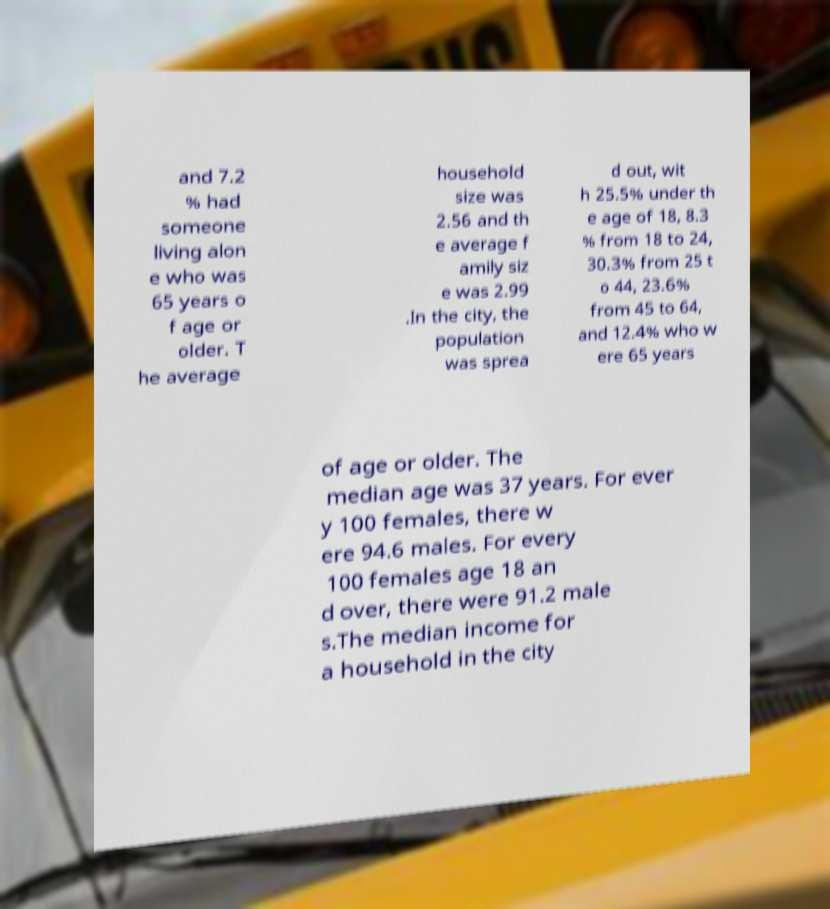What messages or text are displayed in this image? I need them in a readable, typed format. and 7.2 % had someone living alon e who was 65 years o f age or older. T he average household size was 2.56 and th e average f amily siz e was 2.99 .In the city, the population was sprea d out, wit h 25.5% under th e age of 18, 8.3 % from 18 to 24, 30.3% from 25 t o 44, 23.6% from 45 to 64, and 12.4% who w ere 65 years of age or older. The median age was 37 years. For ever y 100 females, there w ere 94.6 males. For every 100 females age 18 an d over, there were 91.2 male s.The median income for a household in the city 